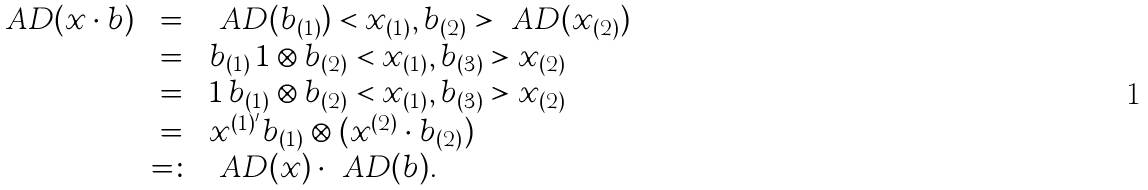<formula> <loc_0><loc_0><loc_500><loc_500>\begin{array} { r c l } \ A D ( x \cdot b ) & = & \ A D ( b _ { ( 1 ) } ) < x _ { ( 1 ) } , b _ { ( 2 ) } > \ A D ( x _ { ( 2 ) } ) \\ & = & b _ { ( 1 ) } \, 1 \otimes b _ { ( 2 ) } < x _ { ( 1 ) } , b _ { ( 3 ) } > x _ { ( 2 ) } \\ & = & 1 \, b _ { ( 1 ) } \otimes b _ { ( 2 ) } < x _ { ( 1 ) } , b _ { ( 3 ) } > x _ { ( 2 ) } \\ & = & x ^ { ( 1 ) ^ { \prime } } b _ { ( 1 ) } \otimes ( x ^ { ( 2 ) } \cdot b _ { ( 2 ) } ) \\ & = \colon & \ A D ( x ) \cdot \ A D ( b ) . \end{array}</formula> 